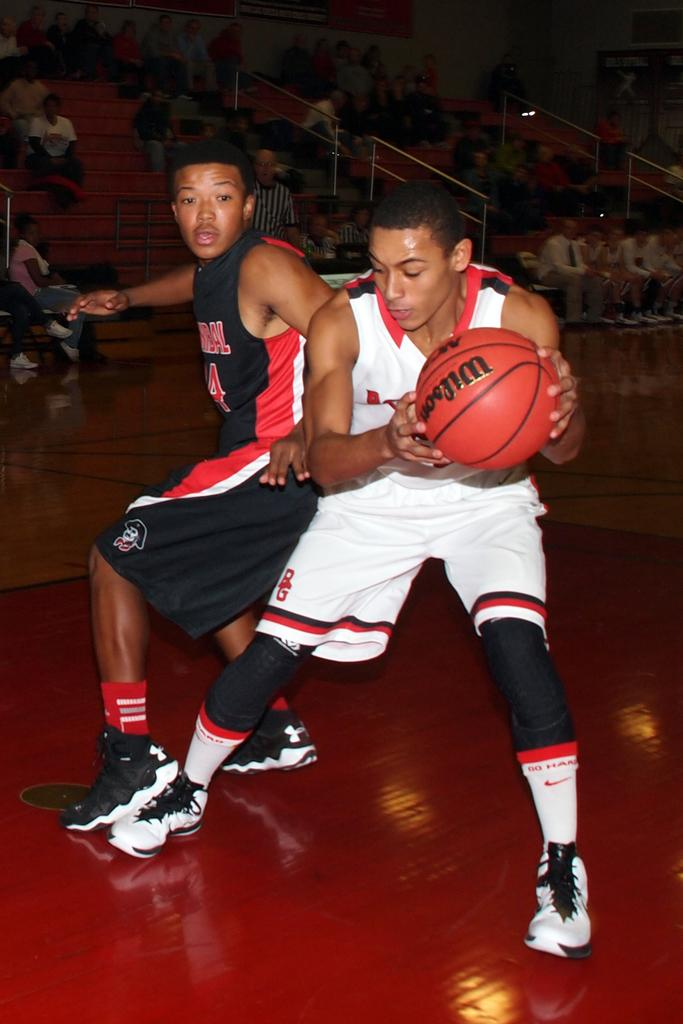<image>
Present a compact description of the photo's key features. A young man holds out a Wilson basketball so the other player can't reach it. 